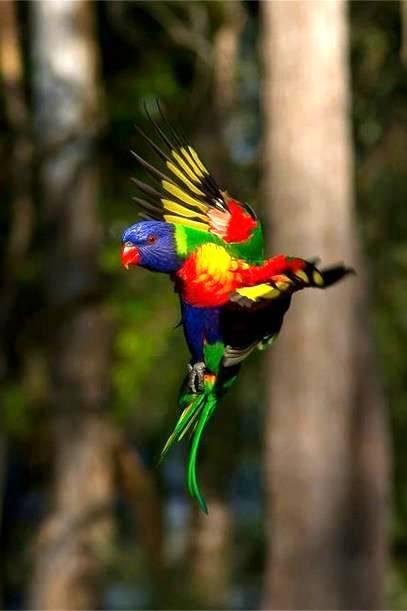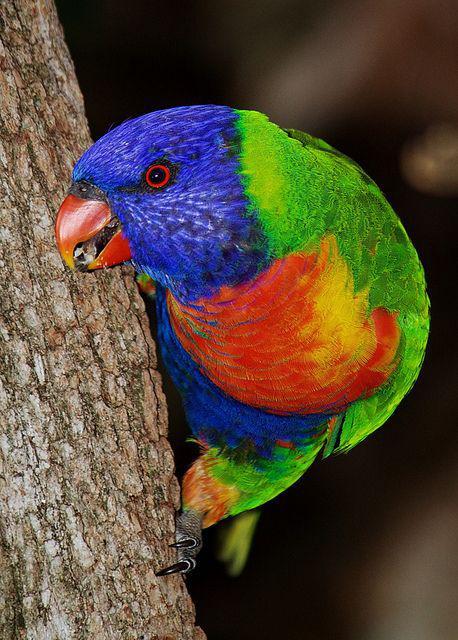The first image is the image on the left, the second image is the image on the right. For the images displayed, is the sentence "There are no more than three birds" factually correct? Answer yes or no. Yes. The first image is the image on the left, the second image is the image on the right. Analyze the images presented: Is the assertion "One image contains at least three similarly colored parrots." valid? Answer yes or no. No. The first image is the image on the left, the second image is the image on the right. Analyze the images presented: Is the assertion "The right and left images contain the same number of parrots." valid? Answer yes or no. Yes. 